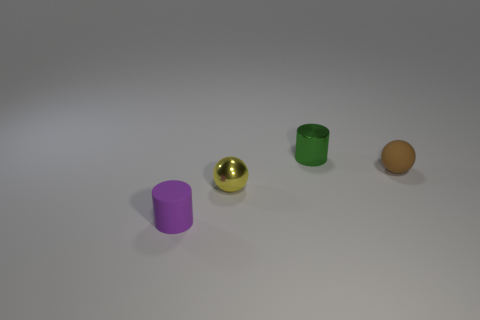What is the color of the shiny cylinder?
Offer a terse response. Green. Are there any objects that are in front of the metal thing in front of the tiny brown thing?
Make the answer very short. Yes. What is the material of the small purple cylinder?
Give a very brief answer. Rubber. Is the material of the tiny cylinder to the left of the green shiny cylinder the same as the small ball that is to the right of the tiny green metal thing?
Keep it short and to the point. Yes. Are there any other things of the same color as the small rubber cylinder?
Your answer should be compact. No. What is the color of the other object that is the same shape as the tiny yellow metal object?
Offer a very short reply. Brown. There is a object that is both on the right side of the purple matte cylinder and left of the green thing; what is its size?
Give a very brief answer. Small. There is a tiny green thing that is on the right side of the purple cylinder; is its shape the same as the tiny object that is on the left side of the small yellow object?
Provide a short and direct response. Yes. What number of brown spheres are made of the same material as the small green cylinder?
Your response must be concise. 0. The thing that is both in front of the small brown sphere and on the right side of the tiny purple cylinder has what shape?
Give a very brief answer. Sphere. 